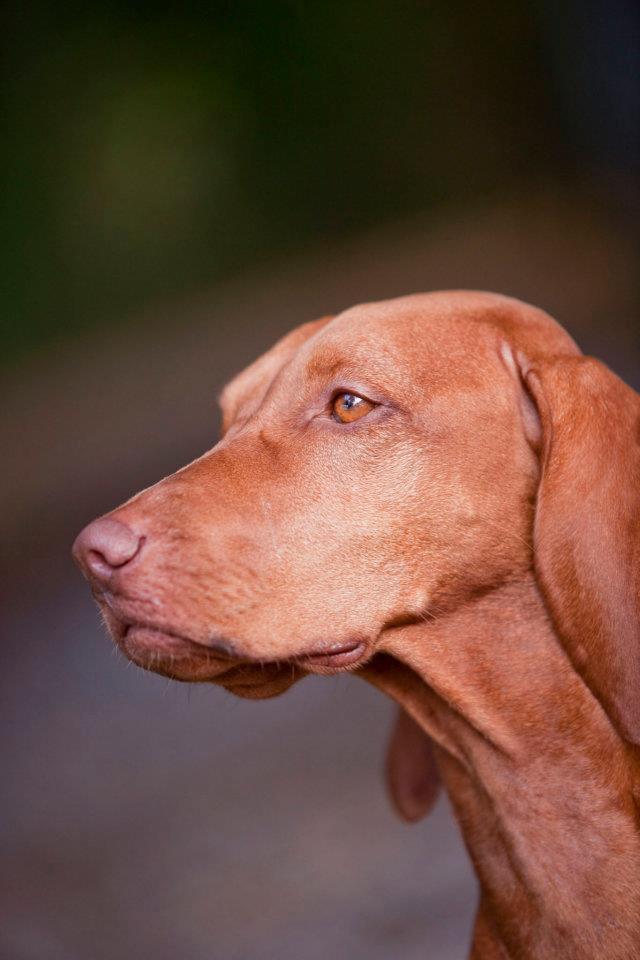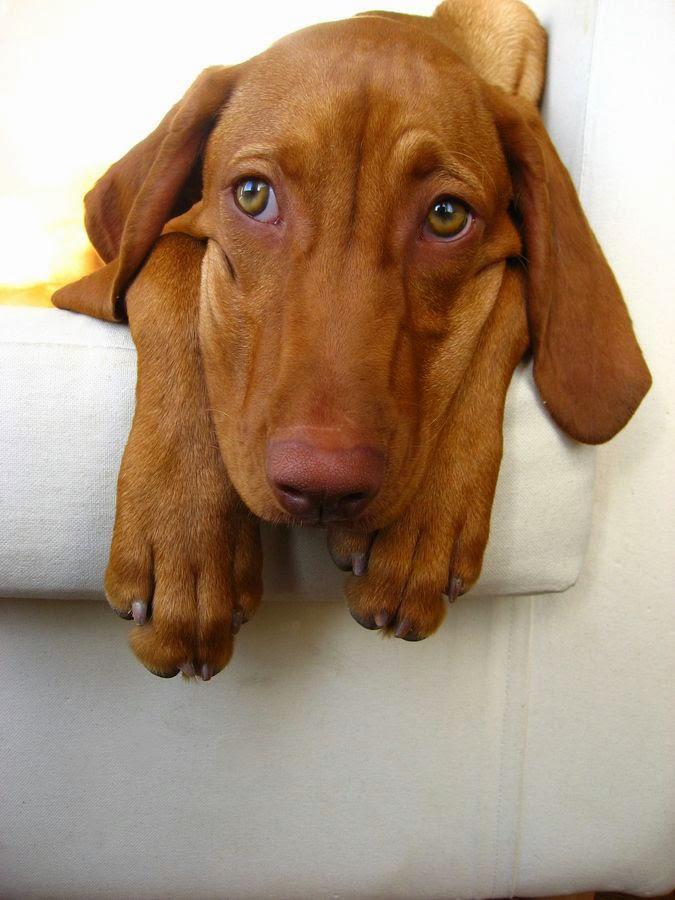The first image is the image on the left, the second image is the image on the right. Examine the images to the left and right. Is the description "The left image shows one dog gazing with an upright head, and the right image shows a dog reclining with its front paws forward and its head rightside-up." accurate? Answer yes or no. Yes. 